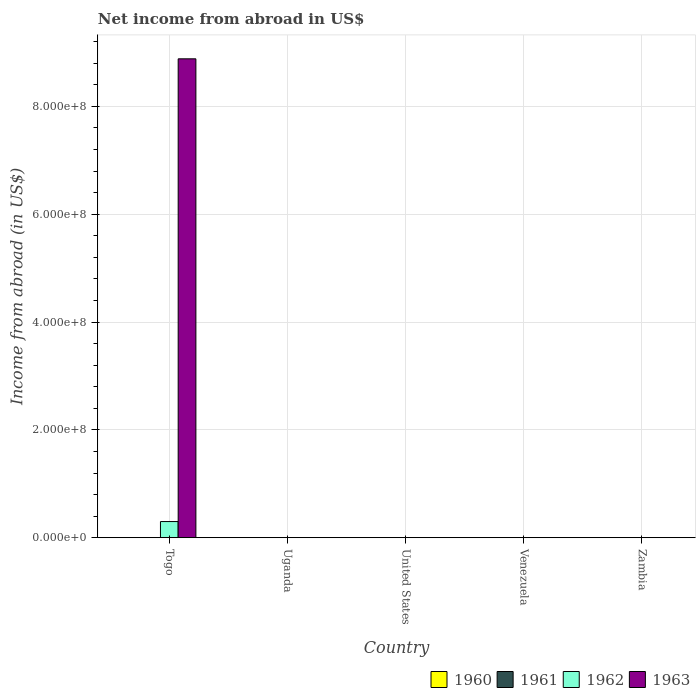How many different coloured bars are there?
Provide a succinct answer. 2. Are the number of bars per tick equal to the number of legend labels?
Offer a very short reply. No. Are the number of bars on each tick of the X-axis equal?
Give a very brief answer. No. How many bars are there on the 3rd tick from the left?
Offer a very short reply. 0. What is the label of the 4th group of bars from the left?
Give a very brief answer. Venezuela. In how many cases, is the number of bars for a given country not equal to the number of legend labels?
Give a very brief answer. 5. What is the net income from abroad in 1963 in Togo?
Your response must be concise. 8.88e+08. Across all countries, what is the maximum net income from abroad in 1963?
Your answer should be compact. 8.88e+08. Across all countries, what is the minimum net income from abroad in 1961?
Provide a succinct answer. 0. In which country was the net income from abroad in 1963 maximum?
Offer a very short reply. Togo. What is the total net income from abroad in 1962 in the graph?
Your answer should be very brief. 3.00e+07. What is the average net income from abroad in 1961 per country?
Offer a very short reply. 0. What is the difference between the highest and the lowest net income from abroad in 1963?
Provide a short and direct response. 8.88e+08. In how many countries, is the net income from abroad in 1960 greater than the average net income from abroad in 1960 taken over all countries?
Provide a succinct answer. 0. Is it the case that in every country, the sum of the net income from abroad in 1963 and net income from abroad in 1962 is greater than the sum of net income from abroad in 1960 and net income from abroad in 1961?
Offer a terse response. No. Are all the bars in the graph horizontal?
Ensure brevity in your answer.  No. What is the difference between two consecutive major ticks on the Y-axis?
Keep it short and to the point. 2.00e+08. Does the graph contain grids?
Make the answer very short. Yes. Where does the legend appear in the graph?
Provide a short and direct response. Bottom right. What is the title of the graph?
Your response must be concise. Net income from abroad in US$. What is the label or title of the Y-axis?
Provide a short and direct response. Income from abroad (in US$). What is the Income from abroad (in US$) of 1962 in Togo?
Keep it short and to the point. 3.00e+07. What is the Income from abroad (in US$) of 1963 in Togo?
Provide a short and direct response. 8.88e+08. What is the Income from abroad (in US$) of 1960 in Uganda?
Offer a very short reply. 0. What is the Income from abroad (in US$) in 1961 in Uganda?
Keep it short and to the point. 0. What is the Income from abroad (in US$) in 1962 in Uganda?
Your answer should be compact. 0. What is the Income from abroad (in US$) in 1963 in Uganda?
Provide a succinct answer. 0. What is the Income from abroad (in US$) of 1960 in United States?
Make the answer very short. 0. What is the Income from abroad (in US$) in 1961 in United States?
Your answer should be very brief. 0. What is the Income from abroad (in US$) of 1963 in United States?
Your answer should be very brief. 0. What is the Income from abroad (in US$) in 1960 in Venezuela?
Ensure brevity in your answer.  0. What is the Income from abroad (in US$) of 1961 in Venezuela?
Your response must be concise. 0. What is the Income from abroad (in US$) in 1962 in Venezuela?
Keep it short and to the point. 0. What is the Income from abroad (in US$) of 1963 in Venezuela?
Make the answer very short. 0. What is the Income from abroad (in US$) of 1960 in Zambia?
Your response must be concise. 0. What is the Income from abroad (in US$) of 1963 in Zambia?
Your answer should be compact. 0. Across all countries, what is the maximum Income from abroad (in US$) of 1962?
Keep it short and to the point. 3.00e+07. Across all countries, what is the maximum Income from abroad (in US$) of 1963?
Provide a succinct answer. 8.88e+08. Across all countries, what is the minimum Income from abroad (in US$) in 1963?
Provide a succinct answer. 0. What is the total Income from abroad (in US$) in 1960 in the graph?
Offer a terse response. 0. What is the total Income from abroad (in US$) of 1961 in the graph?
Your answer should be compact. 0. What is the total Income from abroad (in US$) in 1962 in the graph?
Keep it short and to the point. 3.00e+07. What is the total Income from abroad (in US$) of 1963 in the graph?
Offer a terse response. 8.88e+08. What is the average Income from abroad (in US$) of 1960 per country?
Offer a terse response. 0. What is the average Income from abroad (in US$) in 1962 per country?
Make the answer very short. 5.99e+06. What is the average Income from abroad (in US$) of 1963 per country?
Your answer should be very brief. 1.78e+08. What is the difference between the Income from abroad (in US$) of 1962 and Income from abroad (in US$) of 1963 in Togo?
Give a very brief answer. -8.58e+08. What is the difference between the highest and the lowest Income from abroad (in US$) of 1962?
Provide a short and direct response. 3.00e+07. What is the difference between the highest and the lowest Income from abroad (in US$) in 1963?
Offer a terse response. 8.88e+08. 